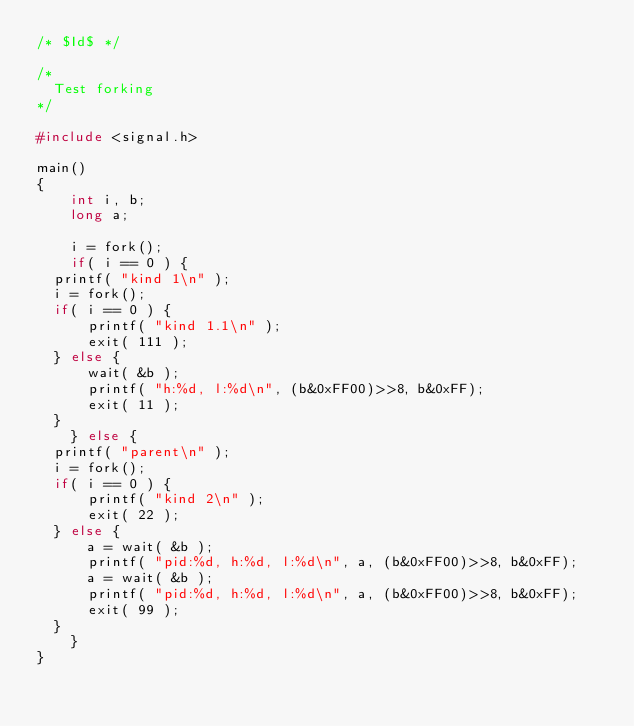Convert code to text. <code><loc_0><loc_0><loc_500><loc_500><_C_>/* $Id$ */

/*
	Test forking
*/

#include <signal.h>

main()
{
    int i, b;
    long a;

    i = fork();
    if( i == 0 ) {
	printf( "kind 1\n" );
	i = fork();
	if( i == 0 ) {
	    printf( "kind 1.1\n" );
	    exit( 111 );
	} else {
	    wait( &b );
	    printf( "h:%d, l:%d\n", (b&0xFF00)>>8, b&0xFF);
	    exit( 11 );
	}
    } else {
	printf( "parent\n" );
	i = fork();
	if( i == 0 ) {
	    printf( "kind 2\n" );
	    exit( 22 );
	} else {
	    a = wait( &b );
	    printf( "pid:%d, h:%d, l:%d\n", a, (b&0xFF00)>>8, b&0xFF);
	    a = wait( &b );
	    printf( "pid:%d, h:%d, l:%d\n", a, (b&0xFF00)>>8, b&0xFF);
	    exit( 99 );
	}
    }
}
</code> 